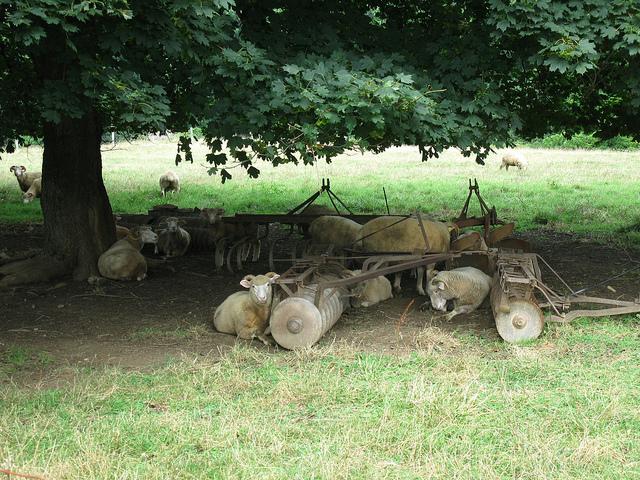Is the tree big?
Short answer required. Yes. What are the animals in the picture sitting under?
Write a very short answer. Tree. What are the animals sitting under?
Be succinct. Tree. 